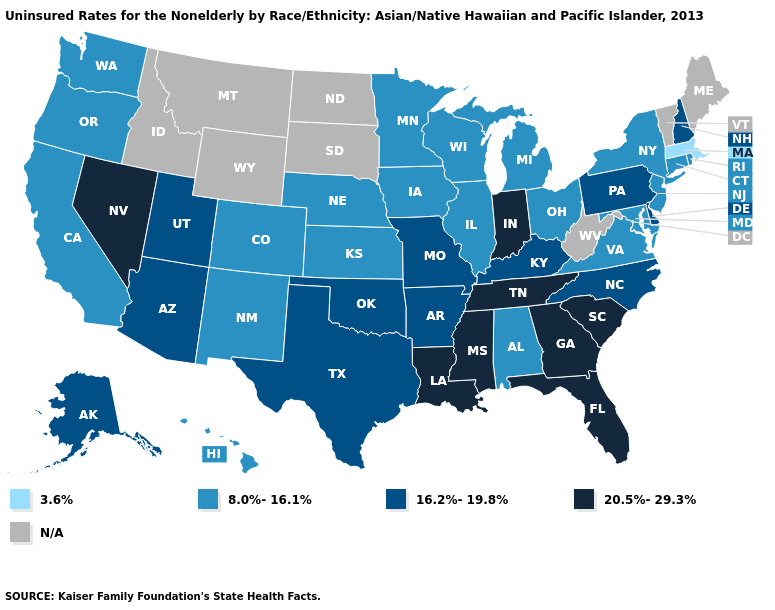Among the states that border Arkansas , which have the lowest value?
Keep it brief. Missouri, Oklahoma, Texas. Name the states that have a value in the range 20.5%-29.3%?
Write a very short answer. Florida, Georgia, Indiana, Louisiana, Mississippi, Nevada, South Carolina, Tennessee. What is the lowest value in states that border Oklahoma?
Keep it brief. 8.0%-16.1%. Name the states that have a value in the range 3.6%?
Give a very brief answer. Massachusetts. What is the value of Wyoming?
Concise answer only. N/A. Name the states that have a value in the range 8.0%-16.1%?
Be succinct. Alabama, California, Colorado, Connecticut, Hawaii, Illinois, Iowa, Kansas, Maryland, Michigan, Minnesota, Nebraska, New Jersey, New Mexico, New York, Ohio, Oregon, Rhode Island, Virginia, Washington, Wisconsin. Among the states that border New Hampshire , which have the highest value?
Keep it brief. Massachusetts. What is the lowest value in states that border Vermont?
Write a very short answer. 3.6%. Does Oregon have the lowest value in the USA?
Be succinct. No. Name the states that have a value in the range 16.2%-19.8%?
Answer briefly. Alaska, Arizona, Arkansas, Delaware, Kentucky, Missouri, New Hampshire, North Carolina, Oklahoma, Pennsylvania, Texas, Utah. What is the value of Nebraska?
Write a very short answer. 8.0%-16.1%. What is the highest value in states that border South Carolina?
Concise answer only. 20.5%-29.3%. Name the states that have a value in the range 16.2%-19.8%?
Answer briefly. Alaska, Arizona, Arkansas, Delaware, Kentucky, Missouri, New Hampshire, North Carolina, Oklahoma, Pennsylvania, Texas, Utah. Name the states that have a value in the range N/A?
Answer briefly. Idaho, Maine, Montana, North Dakota, South Dakota, Vermont, West Virginia, Wyoming. Name the states that have a value in the range 20.5%-29.3%?
Write a very short answer. Florida, Georgia, Indiana, Louisiana, Mississippi, Nevada, South Carolina, Tennessee. 